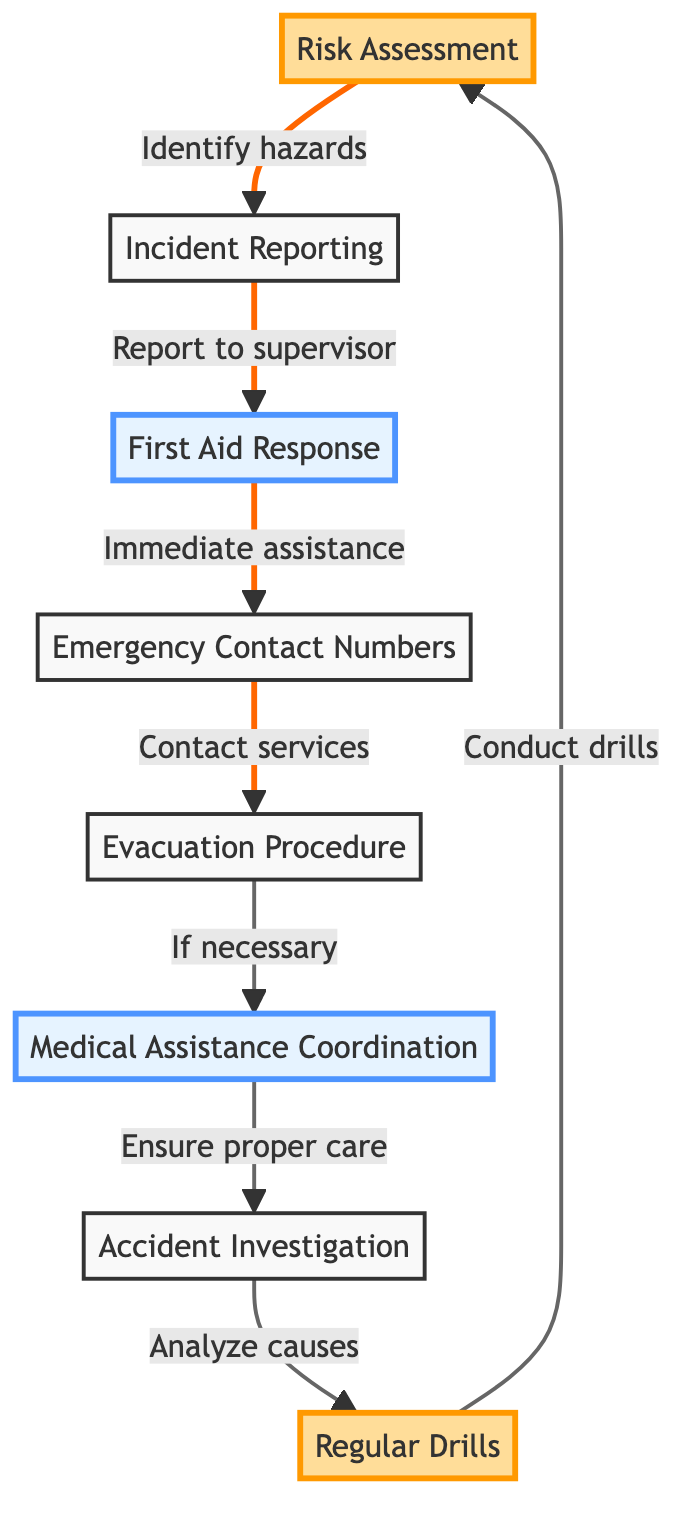What is the starting point of the diagram? The starting point of the diagram is "Risk Assessment," which identifies potential hazards on-site as the first step in the emergency response plan.
Answer: Risk Assessment How many main nodes are there in the diagram? The diagram consists of 8 main nodes, including Risk Assessment, Incident Reporting, First Aid Response, Emergency Contact Numbers, Evacuation Procedure, Medical Assistance Coordination, Accident Investigation, and Regular Drills.
Answer: 8 What is the last action in the sequence of the diagram? The last action in the sequence is "Regular Drills," which emphasizes the importance of conducting regular emergency response drills with all site personnel.
Answer: Regular Drills Which node provides immediate medical assistance? The node that provides immediate medical assistance is "First Aid Response," which follows the "Incident Reporting" node in the sequence.
Answer: First Aid Response What follows after the "Evacuation Procedure" node? After the "Evacuation Procedure" node, the next action is "Medical Assistance Coordination," which ensures that injured personnel receive appropriate medical care.
Answer: Medical Assistance Coordination How does "Accident Investigation" contribute to the overall plan? "Accident Investigation" analyzes the causes of accidents and outlines necessary measures to prevent recurrence, which helps improve safety and response to future incidents.
Answer: Analyze causes Which nodes are highlighted in the diagram? The highlighted nodes in the diagram are "Risk Assessment" and "Regular Drills," indicating their significant roles in the overall emergency response plan.
Answer: Risk Assessment, Regular Drills What is the relationship between "Incident Reporting" and "First Aid Response"? The relationship is that "Incident Reporting" requires reporting accidents to the site supervisor, which leads to the "First Aid Response" for immediate assistance.
Answer: Report to supervisor What is the purpose of "Emergency Contact Numbers"? The purpose of "Emergency Contact Numbers" is to provide a list of important contacts, such as fire department, local hospitals, and emergency services, necessary for responding to emergencies.
Answer: List of important contacts 